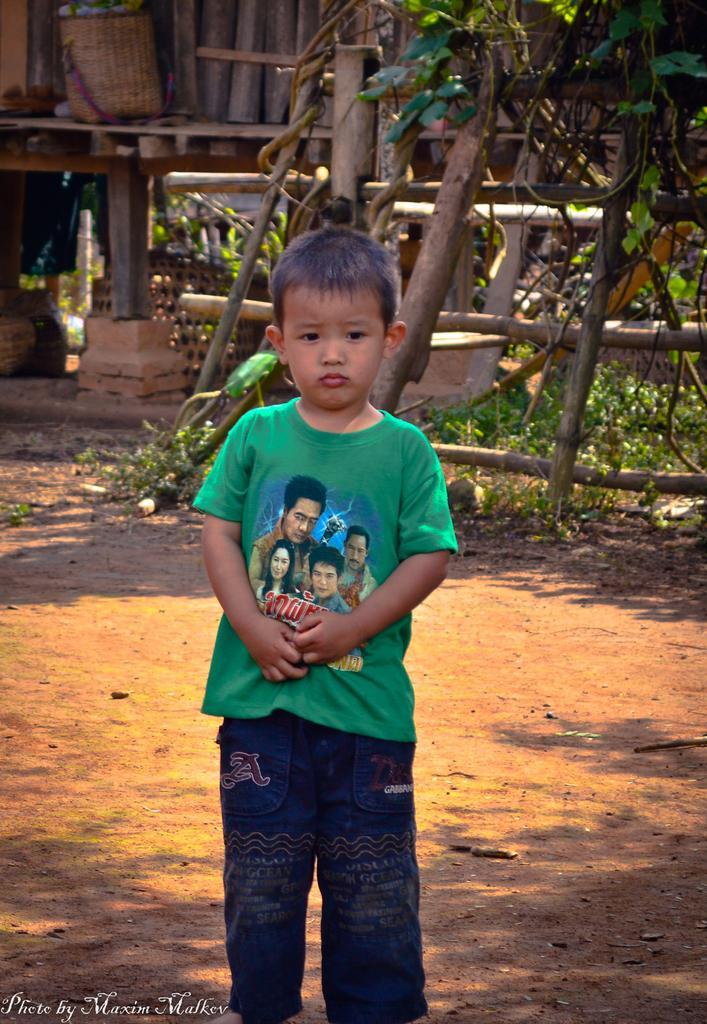How would you summarize this image in a sentence or two? In this image we can see some text on the bottom left side of the image, one boy standing in the middle of the image, some flowers in the basket, one object looks like a wooden wall, some poles, some objects in the background, some plants and grass on the ground. 